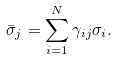<formula> <loc_0><loc_0><loc_500><loc_500>\bar { \sigma } _ { j } = \sum _ { i = 1 } ^ { N } \gamma _ { i j } \sigma _ { i } .</formula> 